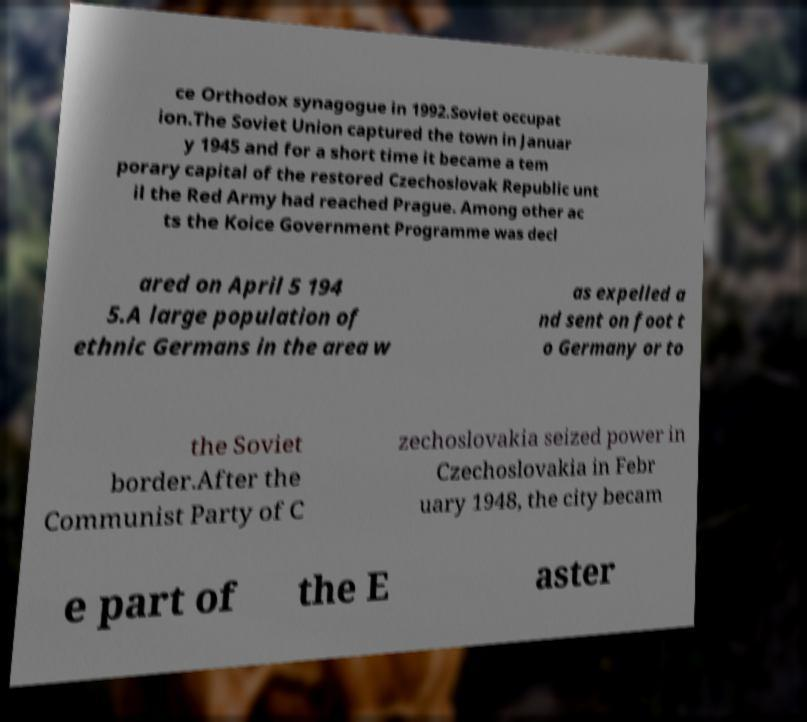Could you assist in decoding the text presented in this image and type it out clearly? ce Orthodox synagogue in 1992.Soviet occupat ion.The Soviet Union captured the town in Januar y 1945 and for a short time it became a tem porary capital of the restored Czechoslovak Republic unt il the Red Army had reached Prague. Among other ac ts the Koice Government Programme was decl ared on April 5 194 5.A large population of ethnic Germans in the area w as expelled a nd sent on foot t o Germany or to the Soviet border.After the Communist Party of C zechoslovakia seized power in Czechoslovakia in Febr uary 1948, the city becam e part of the E aster 